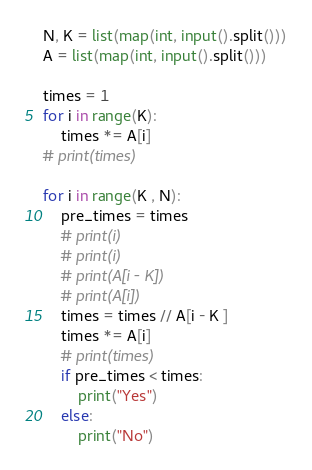<code> <loc_0><loc_0><loc_500><loc_500><_Python_>N, K = list(map(int, input().split()))
A = list(map(int, input().split()))

times = 1
for i in range(K):
    times *= A[i]
# print(times)

for i in range(K , N):
    pre_times = times
    # print(i)
    # print(i)
    # print(A[i - K])
    # print(A[i])
    times = times // A[i - K ]
    times *= A[i]
    # print(times)
    if pre_times < times:
        print("Yes")
    else:
        print("No")</code> 